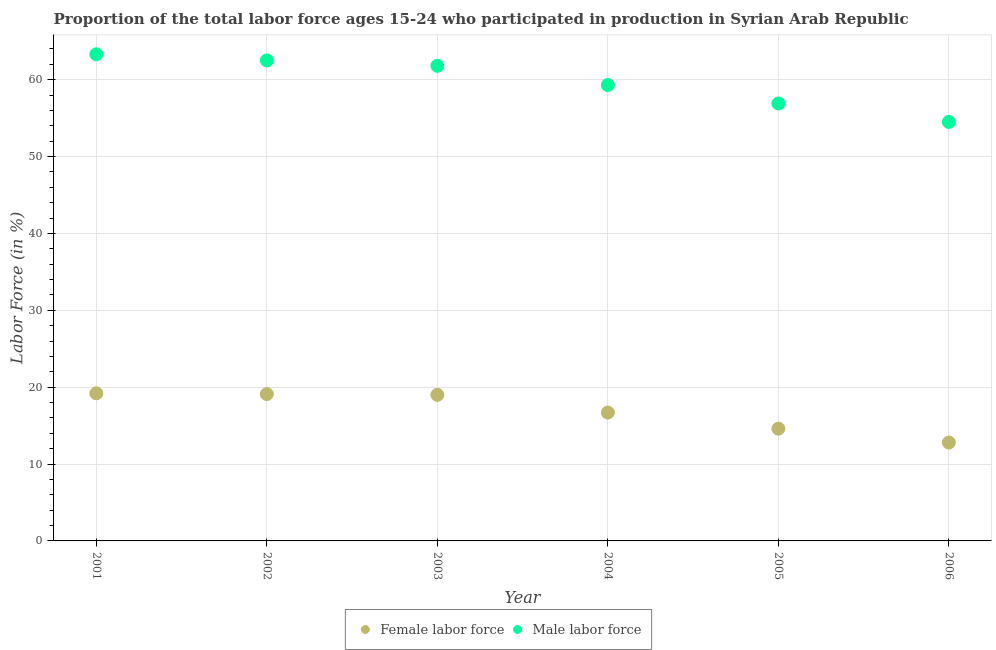How many different coloured dotlines are there?
Ensure brevity in your answer.  2. What is the percentage of male labour force in 2002?
Your answer should be compact. 62.5. Across all years, what is the maximum percentage of female labor force?
Offer a terse response. 19.2. Across all years, what is the minimum percentage of female labor force?
Ensure brevity in your answer.  12.8. What is the total percentage of male labour force in the graph?
Your answer should be very brief. 358.3. What is the difference between the percentage of male labour force in 2001 and that in 2004?
Offer a terse response. 4. What is the difference between the percentage of male labour force in 2003 and the percentage of female labor force in 2001?
Your response must be concise. 42.6. What is the average percentage of female labor force per year?
Offer a very short reply. 16.9. In the year 2004, what is the difference between the percentage of male labour force and percentage of female labor force?
Ensure brevity in your answer.  42.6. What is the ratio of the percentage of male labour force in 2002 to that in 2006?
Provide a short and direct response. 1.15. Is the percentage of male labour force in 2002 less than that in 2006?
Provide a short and direct response. No. What is the difference between the highest and the second highest percentage of male labour force?
Your answer should be very brief. 0.8. What is the difference between the highest and the lowest percentage of female labor force?
Ensure brevity in your answer.  6.4. In how many years, is the percentage of male labour force greater than the average percentage of male labour force taken over all years?
Offer a very short reply. 3. Is the sum of the percentage of male labour force in 2001 and 2002 greater than the maximum percentage of female labor force across all years?
Provide a short and direct response. Yes. Does the percentage of male labour force monotonically increase over the years?
Your answer should be very brief. No. Is the percentage of female labor force strictly less than the percentage of male labour force over the years?
Your answer should be compact. Yes. How many years are there in the graph?
Keep it short and to the point. 6. What is the difference between two consecutive major ticks on the Y-axis?
Offer a terse response. 10. Does the graph contain any zero values?
Offer a very short reply. No. Does the graph contain grids?
Offer a terse response. Yes. How are the legend labels stacked?
Provide a short and direct response. Horizontal. What is the title of the graph?
Provide a short and direct response. Proportion of the total labor force ages 15-24 who participated in production in Syrian Arab Republic. Does "Export" appear as one of the legend labels in the graph?
Ensure brevity in your answer.  No. What is the label or title of the X-axis?
Make the answer very short. Year. What is the Labor Force (in %) in Female labor force in 2001?
Provide a succinct answer. 19.2. What is the Labor Force (in %) in Male labor force in 2001?
Provide a succinct answer. 63.3. What is the Labor Force (in %) in Female labor force in 2002?
Your answer should be very brief. 19.1. What is the Labor Force (in %) in Male labor force in 2002?
Make the answer very short. 62.5. What is the Labor Force (in %) of Female labor force in 2003?
Keep it short and to the point. 19. What is the Labor Force (in %) of Male labor force in 2003?
Make the answer very short. 61.8. What is the Labor Force (in %) of Female labor force in 2004?
Provide a succinct answer. 16.7. What is the Labor Force (in %) of Male labor force in 2004?
Offer a terse response. 59.3. What is the Labor Force (in %) in Female labor force in 2005?
Provide a short and direct response. 14.6. What is the Labor Force (in %) of Male labor force in 2005?
Give a very brief answer. 56.9. What is the Labor Force (in %) in Female labor force in 2006?
Your answer should be compact. 12.8. What is the Labor Force (in %) in Male labor force in 2006?
Provide a succinct answer. 54.5. Across all years, what is the maximum Labor Force (in %) of Female labor force?
Your answer should be very brief. 19.2. Across all years, what is the maximum Labor Force (in %) of Male labor force?
Your response must be concise. 63.3. Across all years, what is the minimum Labor Force (in %) of Female labor force?
Your answer should be compact. 12.8. Across all years, what is the minimum Labor Force (in %) in Male labor force?
Your response must be concise. 54.5. What is the total Labor Force (in %) of Female labor force in the graph?
Keep it short and to the point. 101.4. What is the total Labor Force (in %) in Male labor force in the graph?
Make the answer very short. 358.3. What is the difference between the Labor Force (in %) in Female labor force in 2001 and that in 2003?
Your response must be concise. 0.2. What is the difference between the Labor Force (in %) in Male labor force in 2001 and that in 2003?
Provide a succinct answer. 1.5. What is the difference between the Labor Force (in %) of Male labor force in 2001 and that in 2005?
Your answer should be very brief. 6.4. What is the difference between the Labor Force (in %) in Female labor force in 2001 and that in 2006?
Provide a short and direct response. 6.4. What is the difference between the Labor Force (in %) of Female labor force in 2002 and that in 2003?
Ensure brevity in your answer.  0.1. What is the difference between the Labor Force (in %) in Male labor force in 2002 and that in 2003?
Keep it short and to the point. 0.7. What is the difference between the Labor Force (in %) in Female labor force in 2002 and that in 2005?
Provide a succinct answer. 4.5. What is the difference between the Labor Force (in %) in Male labor force in 2002 and that in 2005?
Give a very brief answer. 5.6. What is the difference between the Labor Force (in %) of Female labor force in 2002 and that in 2006?
Offer a very short reply. 6.3. What is the difference between the Labor Force (in %) in Male labor force in 2003 and that in 2004?
Give a very brief answer. 2.5. What is the difference between the Labor Force (in %) in Male labor force in 2003 and that in 2005?
Your answer should be very brief. 4.9. What is the difference between the Labor Force (in %) in Female labor force in 2003 and that in 2006?
Give a very brief answer. 6.2. What is the difference between the Labor Force (in %) in Male labor force in 2003 and that in 2006?
Keep it short and to the point. 7.3. What is the difference between the Labor Force (in %) of Male labor force in 2004 and that in 2005?
Offer a very short reply. 2.4. What is the difference between the Labor Force (in %) of Female labor force in 2005 and that in 2006?
Make the answer very short. 1.8. What is the difference between the Labor Force (in %) in Male labor force in 2005 and that in 2006?
Provide a short and direct response. 2.4. What is the difference between the Labor Force (in %) of Female labor force in 2001 and the Labor Force (in %) of Male labor force in 2002?
Your answer should be compact. -43.3. What is the difference between the Labor Force (in %) in Female labor force in 2001 and the Labor Force (in %) in Male labor force in 2003?
Provide a short and direct response. -42.6. What is the difference between the Labor Force (in %) of Female labor force in 2001 and the Labor Force (in %) of Male labor force in 2004?
Your answer should be compact. -40.1. What is the difference between the Labor Force (in %) in Female labor force in 2001 and the Labor Force (in %) in Male labor force in 2005?
Offer a terse response. -37.7. What is the difference between the Labor Force (in %) of Female labor force in 2001 and the Labor Force (in %) of Male labor force in 2006?
Offer a very short reply. -35.3. What is the difference between the Labor Force (in %) in Female labor force in 2002 and the Labor Force (in %) in Male labor force in 2003?
Provide a succinct answer. -42.7. What is the difference between the Labor Force (in %) of Female labor force in 2002 and the Labor Force (in %) of Male labor force in 2004?
Offer a terse response. -40.2. What is the difference between the Labor Force (in %) in Female labor force in 2002 and the Labor Force (in %) in Male labor force in 2005?
Offer a terse response. -37.8. What is the difference between the Labor Force (in %) of Female labor force in 2002 and the Labor Force (in %) of Male labor force in 2006?
Offer a very short reply. -35.4. What is the difference between the Labor Force (in %) in Female labor force in 2003 and the Labor Force (in %) in Male labor force in 2004?
Provide a short and direct response. -40.3. What is the difference between the Labor Force (in %) in Female labor force in 2003 and the Labor Force (in %) in Male labor force in 2005?
Your response must be concise. -37.9. What is the difference between the Labor Force (in %) of Female labor force in 2003 and the Labor Force (in %) of Male labor force in 2006?
Provide a succinct answer. -35.5. What is the difference between the Labor Force (in %) of Female labor force in 2004 and the Labor Force (in %) of Male labor force in 2005?
Your answer should be very brief. -40.2. What is the difference between the Labor Force (in %) in Female labor force in 2004 and the Labor Force (in %) in Male labor force in 2006?
Provide a short and direct response. -37.8. What is the difference between the Labor Force (in %) of Female labor force in 2005 and the Labor Force (in %) of Male labor force in 2006?
Make the answer very short. -39.9. What is the average Labor Force (in %) of Male labor force per year?
Your response must be concise. 59.72. In the year 2001, what is the difference between the Labor Force (in %) of Female labor force and Labor Force (in %) of Male labor force?
Offer a very short reply. -44.1. In the year 2002, what is the difference between the Labor Force (in %) in Female labor force and Labor Force (in %) in Male labor force?
Ensure brevity in your answer.  -43.4. In the year 2003, what is the difference between the Labor Force (in %) in Female labor force and Labor Force (in %) in Male labor force?
Offer a terse response. -42.8. In the year 2004, what is the difference between the Labor Force (in %) in Female labor force and Labor Force (in %) in Male labor force?
Give a very brief answer. -42.6. In the year 2005, what is the difference between the Labor Force (in %) of Female labor force and Labor Force (in %) of Male labor force?
Offer a very short reply. -42.3. In the year 2006, what is the difference between the Labor Force (in %) of Female labor force and Labor Force (in %) of Male labor force?
Make the answer very short. -41.7. What is the ratio of the Labor Force (in %) in Male labor force in 2001 to that in 2002?
Your response must be concise. 1.01. What is the ratio of the Labor Force (in %) in Female labor force in 2001 to that in 2003?
Provide a short and direct response. 1.01. What is the ratio of the Labor Force (in %) in Male labor force in 2001 to that in 2003?
Offer a terse response. 1.02. What is the ratio of the Labor Force (in %) of Female labor force in 2001 to that in 2004?
Give a very brief answer. 1.15. What is the ratio of the Labor Force (in %) in Male labor force in 2001 to that in 2004?
Ensure brevity in your answer.  1.07. What is the ratio of the Labor Force (in %) in Female labor force in 2001 to that in 2005?
Keep it short and to the point. 1.32. What is the ratio of the Labor Force (in %) in Male labor force in 2001 to that in 2005?
Offer a very short reply. 1.11. What is the ratio of the Labor Force (in %) in Male labor force in 2001 to that in 2006?
Offer a terse response. 1.16. What is the ratio of the Labor Force (in %) in Male labor force in 2002 to that in 2003?
Provide a short and direct response. 1.01. What is the ratio of the Labor Force (in %) in Female labor force in 2002 to that in 2004?
Your answer should be very brief. 1.14. What is the ratio of the Labor Force (in %) of Male labor force in 2002 to that in 2004?
Your response must be concise. 1.05. What is the ratio of the Labor Force (in %) in Female labor force in 2002 to that in 2005?
Ensure brevity in your answer.  1.31. What is the ratio of the Labor Force (in %) in Male labor force in 2002 to that in 2005?
Provide a succinct answer. 1.1. What is the ratio of the Labor Force (in %) in Female labor force in 2002 to that in 2006?
Offer a very short reply. 1.49. What is the ratio of the Labor Force (in %) in Male labor force in 2002 to that in 2006?
Keep it short and to the point. 1.15. What is the ratio of the Labor Force (in %) in Female labor force in 2003 to that in 2004?
Provide a succinct answer. 1.14. What is the ratio of the Labor Force (in %) of Male labor force in 2003 to that in 2004?
Give a very brief answer. 1.04. What is the ratio of the Labor Force (in %) in Female labor force in 2003 to that in 2005?
Your response must be concise. 1.3. What is the ratio of the Labor Force (in %) in Male labor force in 2003 to that in 2005?
Your response must be concise. 1.09. What is the ratio of the Labor Force (in %) of Female labor force in 2003 to that in 2006?
Ensure brevity in your answer.  1.48. What is the ratio of the Labor Force (in %) of Male labor force in 2003 to that in 2006?
Keep it short and to the point. 1.13. What is the ratio of the Labor Force (in %) in Female labor force in 2004 to that in 2005?
Offer a very short reply. 1.14. What is the ratio of the Labor Force (in %) of Male labor force in 2004 to that in 2005?
Make the answer very short. 1.04. What is the ratio of the Labor Force (in %) of Female labor force in 2004 to that in 2006?
Provide a succinct answer. 1.3. What is the ratio of the Labor Force (in %) in Male labor force in 2004 to that in 2006?
Give a very brief answer. 1.09. What is the ratio of the Labor Force (in %) in Female labor force in 2005 to that in 2006?
Offer a very short reply. 1.14. What is the ratio of the Labor Force (in %) of Male labor force in 2005 to that in 2006?
Keep it short and to the point. 1.04. 